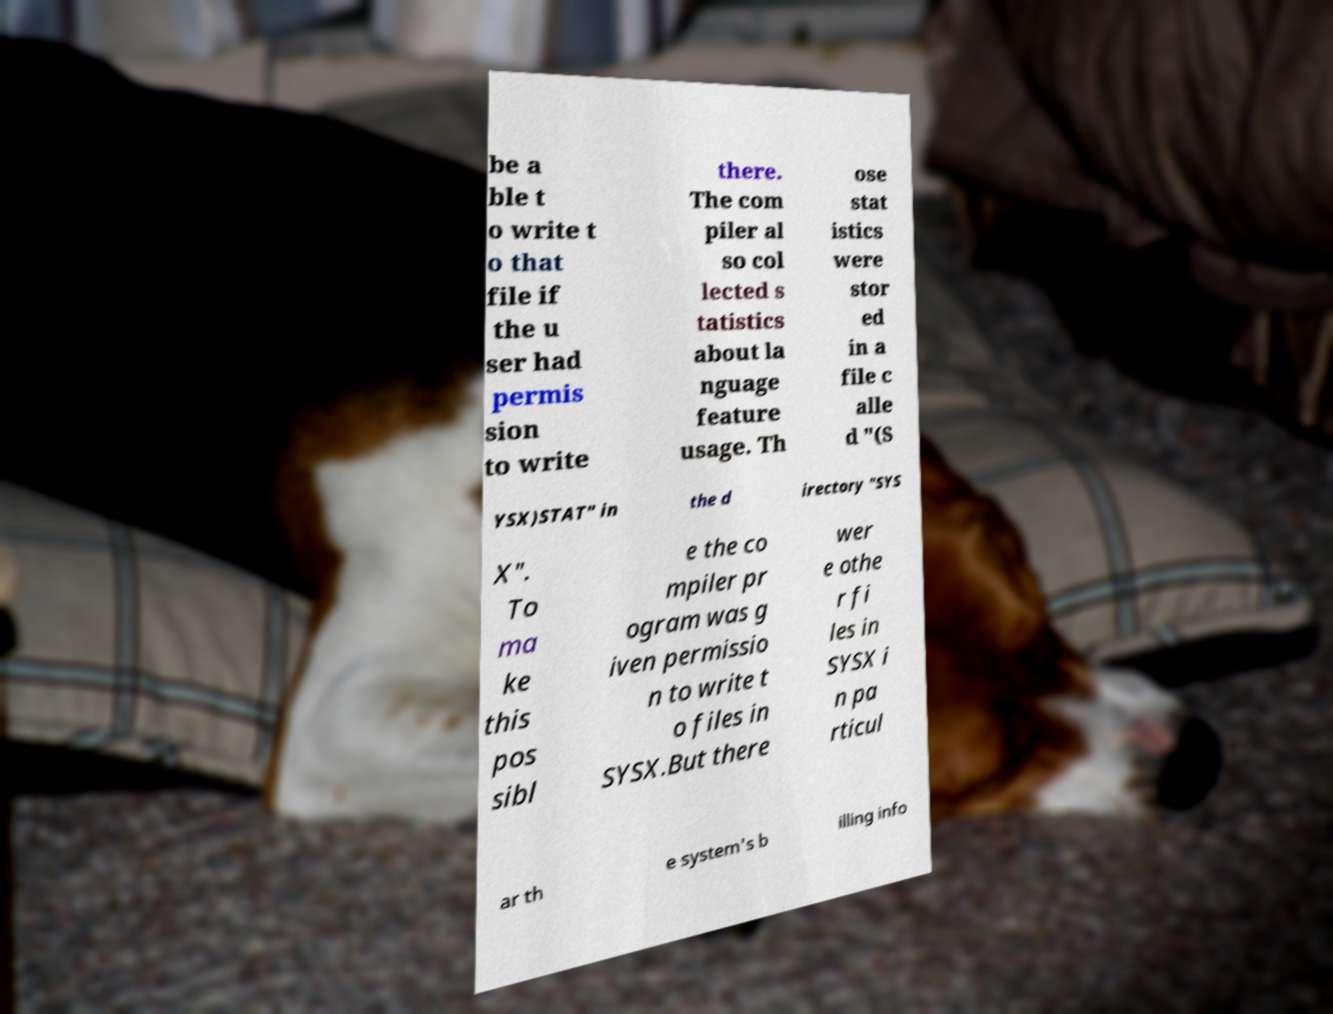Please read and relay the text visible in this image. What does it say? be a ble t o write t o that file if the u ser had permis sion to write there. The com piler al so col lected s tatistics about la nguage feature usage. Th ose stat istics were stor ed in a file c alle d "(S YSX)STAT" in the d irectory "SYS X". To ma ke this pos sibl e the co mpiler pr ogram was g iven permissio n to write t o files in SYSX.But there wer e othe r fi les in SYSX i n pa rticul ar th e system's b illing info 